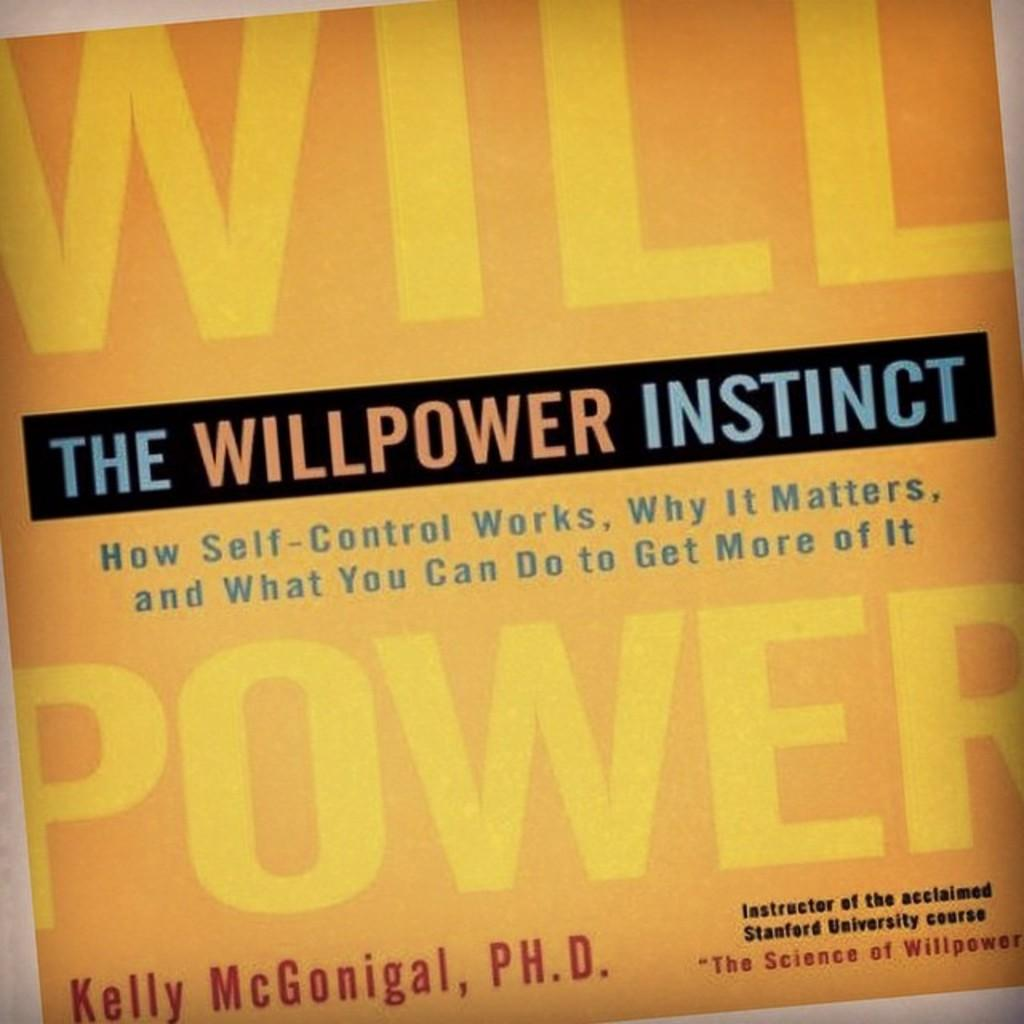<image>
Present a compact description of the photo's key features. A yellow book titled The Willpower Instinct authored by Kelly McGonigal, Ph.D. 